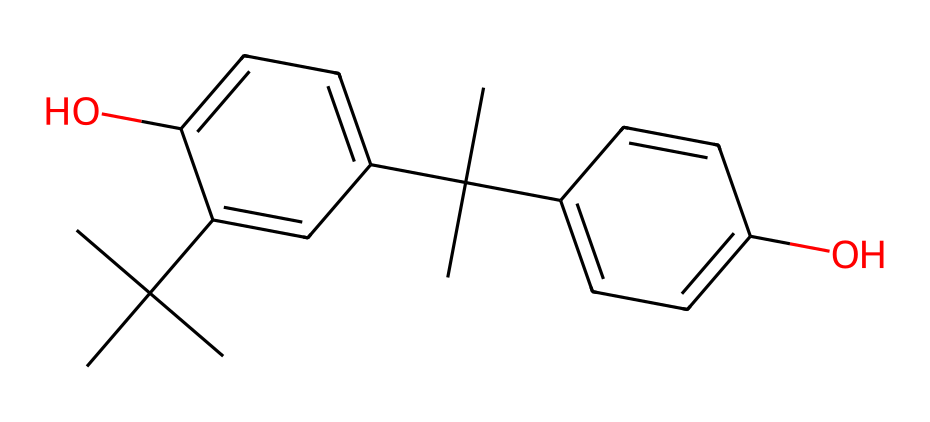What is the molecular formula of the chemical represented? The SMILES representation can be analyzed by counting the carbon (C), hydrogen (H), and oxygen (O) atoms. The structure includes a total of 24 carbon atoms, 34 hydrogen atoms, and 2 oxygen atoms, leading to the molecular formula C24H34O2.
Answer: C24H34O2 How many hydroxyl (−OH) groups are present in this structure? The structure contains two phenolic groups, each contributing one hydroxyl group (−OH). Therefore, there are a total of two −OH groups in the chemical.
Answer: 2 What type of chemical is represented (general category)? The presence of the hydroxyl groups attached to aromatic rings indicates that this compound belongs to the category of phenols, specifically phenolic antioxidants.
Answer: phenol Is this compound likely to be hydrophilic or hydrophobic? The presence of two hydroxyl groups suggests that the compound is more hydrophilic due to the ability of −OH groups to form hydrogen bonds with water molecules, enhancing solubility.
Answer: hydrophilic What is a potential application of this chemical in sunscreen formulations? As a phenolic antioxidant, this chemical can help protect the skin from oxidative damage caused by UV radiation, making it a valuable ingredient in sunscreens.
Answer: antioxidant 